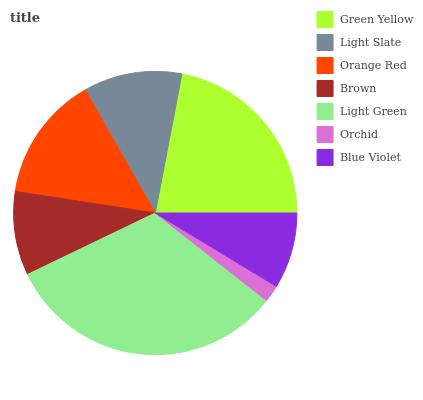Is Orchid the minimum?
Answer yes or no. Yes. Is Light Green the maximum?
Answer yes or no. Yes. Is Light Slate the minimum?
Answer yes or no. No. Is Light Slate the maximum?
Answer yes or no. No. Is Green Yellow greater than Light Slate?
Answer yes or no. Yes. Is Light Slate less than Green Yellow?
Answer yes or no. Yes. Is Light Slate greater than Green Yellow?
Answer yes or no. No. Is Green Yellow less than Light Slate?
Answer yes or no. No. Is Light Slate the high median?
Answer yes or no. Yes. Is Light Slate the low median?
Answer yes or no. Yes. Is Orange Red the high median?
Answer yes or no. No. Is Brown the low median?
Answer yes or no. No. 